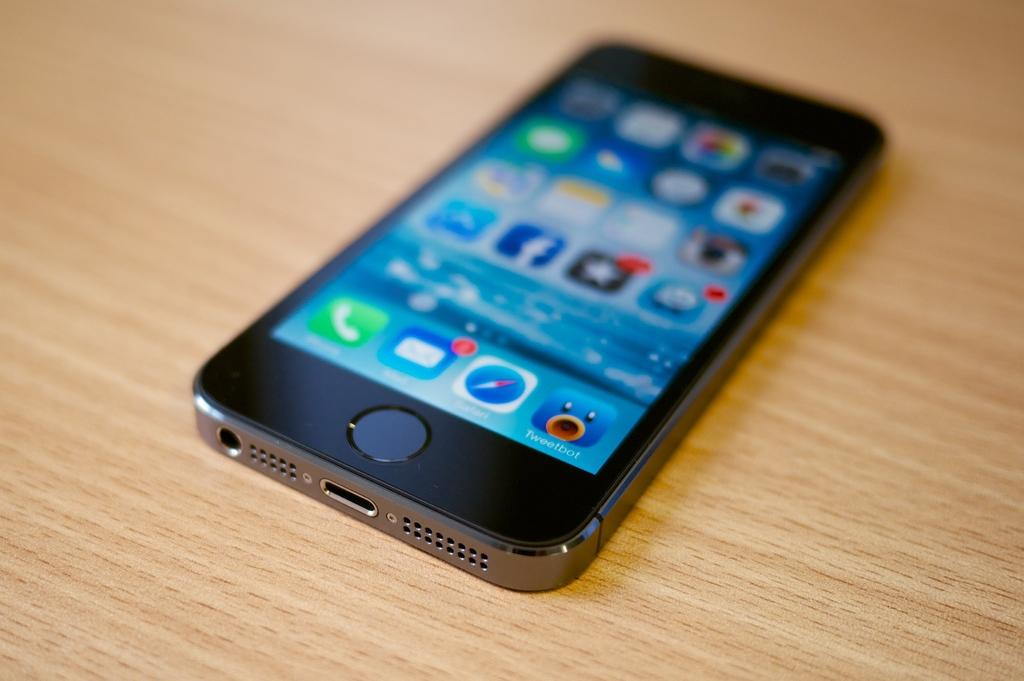Provide a one-sentence caption for the provided image. A cell phone on a table that has a Tweetbot app installed. 